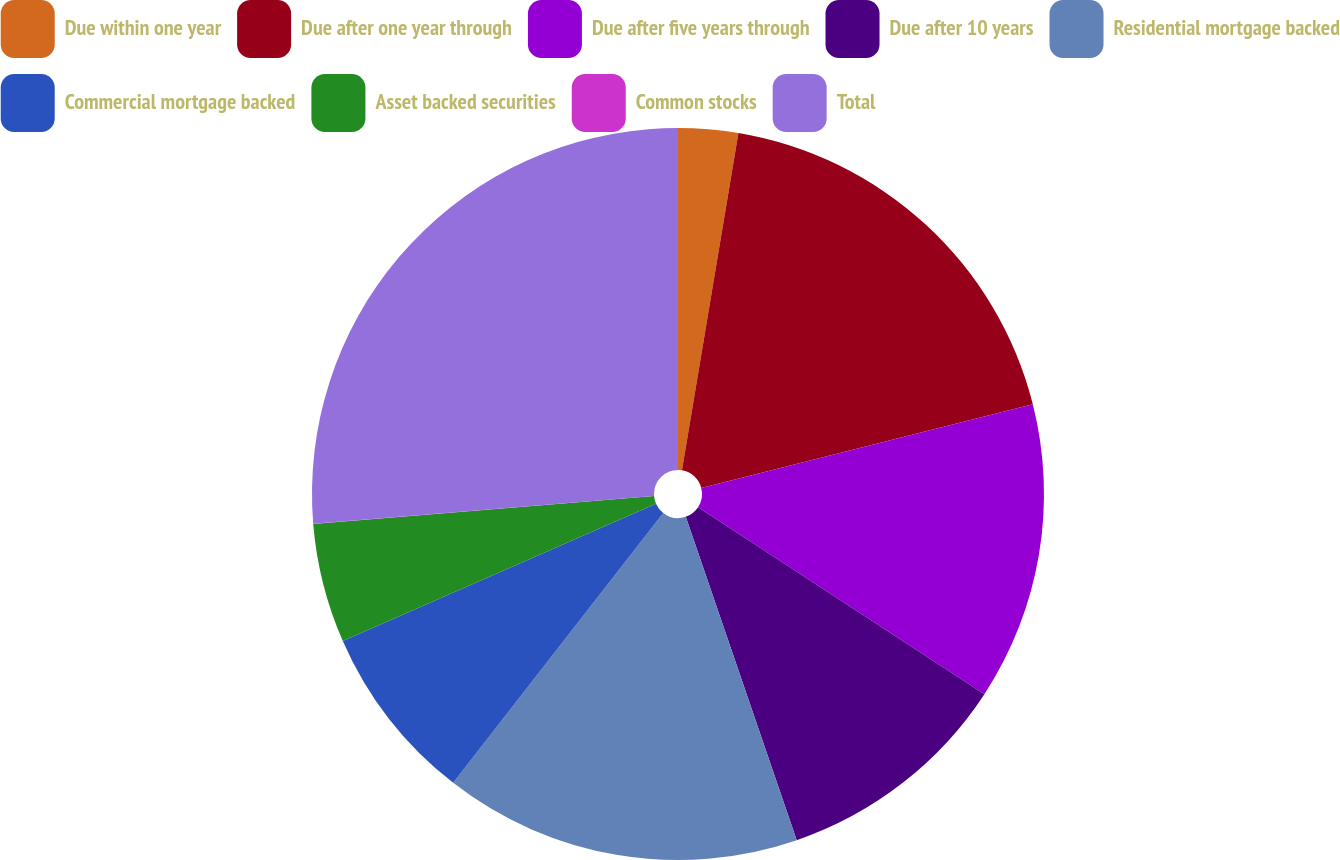<chart> <loc_0><loc_0><loc_500><loc_500><pie_chart><fcel>Due within one year<fcel>Due after one year through<fcel>Due after five years through<fcel>Due after 10 years<fcel>Residential mortgage backed<fcel>Commercial mortgage backed<fcel>Asset backed securities<fcel>Common stocks<fcel>Total<nl><fcel>2.64%<fcel>18.42%<fcel>13.16%<fcel>10.53%<fcel>15.79%<fcel>7.9%<fcel>5.27%<fcel>0.01%<fcel>26.3%<nl></chart> 